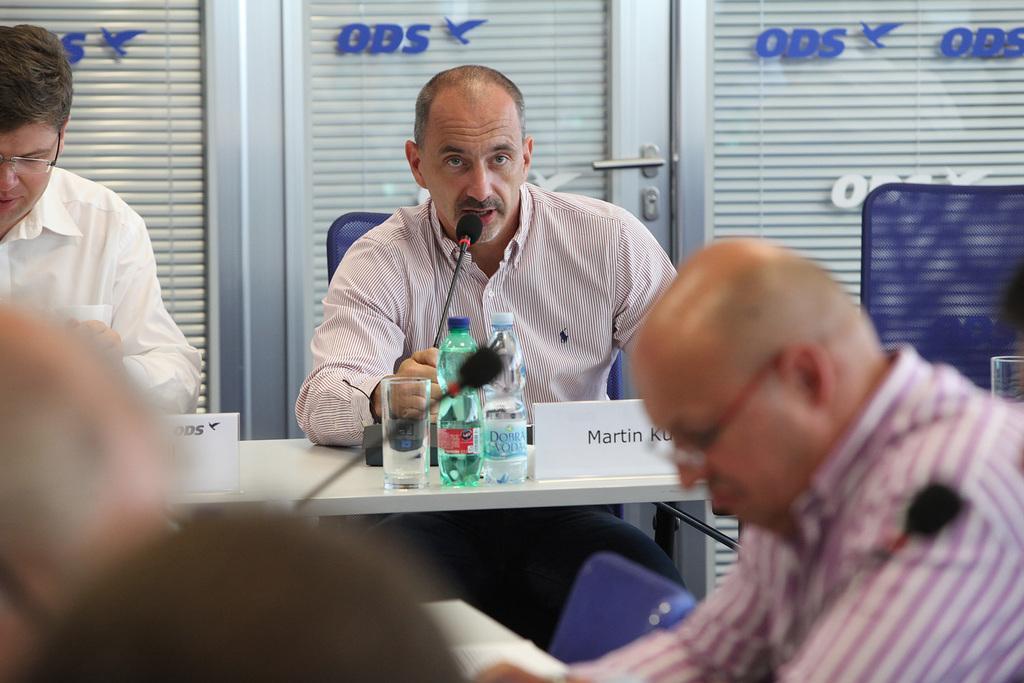Please provide a concise description of this image. To the left side there is a man with white shirt and spectacles is sitting. Beside him there is a man with checks is sitting on a blue chair he is holding a mic and he is speaking. In front of them there is a table with glass, two bottles, name board and a mic. To the right side there is a man with white and violet lines shirt is sitting and he is having spectacles. To the right side top there is a blue chair. And in the middle there is a door. 